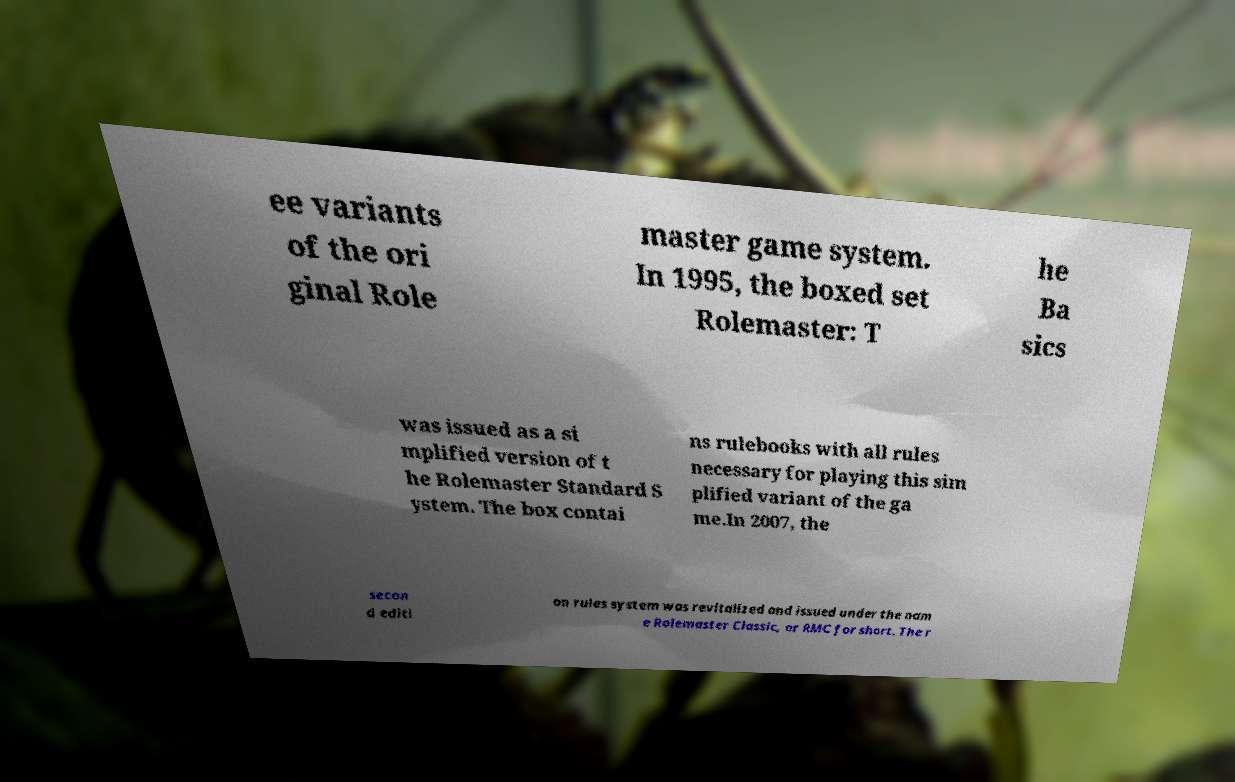Please identify and transcribe the text found in this image. ee variants of the ori ginal Role master game system. In 1995, the boxed set Rolemaster: T he Ba sics was issued as a si mplified version of t he Rolemaster Standard S ystem. The box contai ns rulebooks with all rules necessary for playing this sim plified variant of the ga me.In 2007, the secon d editi on rules system was revitalized and issued under the nam e Rolemaster Classic, or RMC for short. The r 